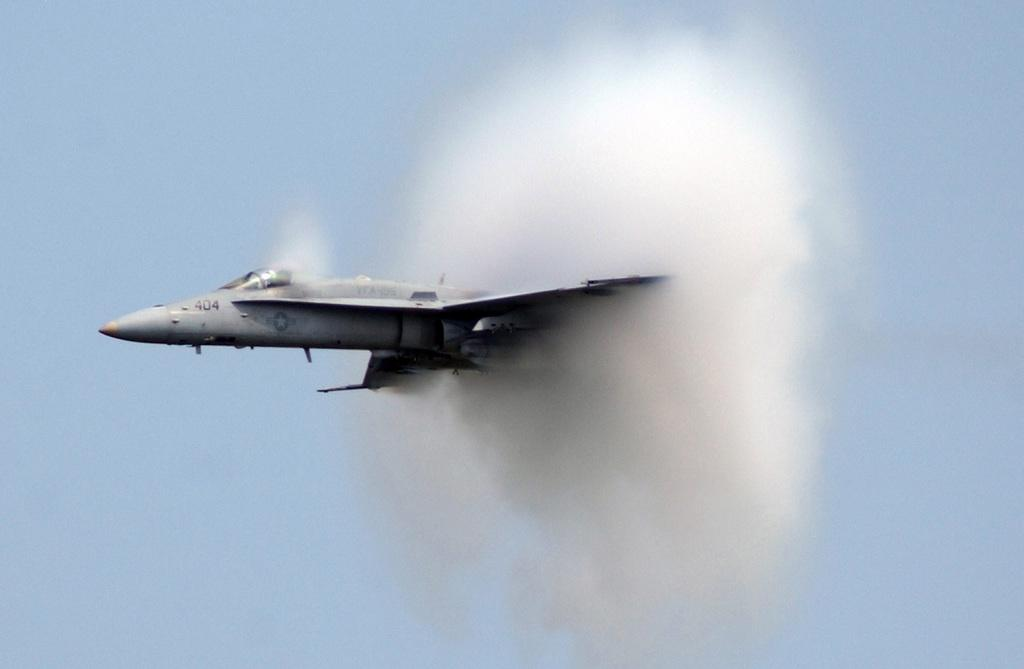Provide a one-sentence caption for the provided image. plane 404 with smoke coming out of its tail up in the sky. 